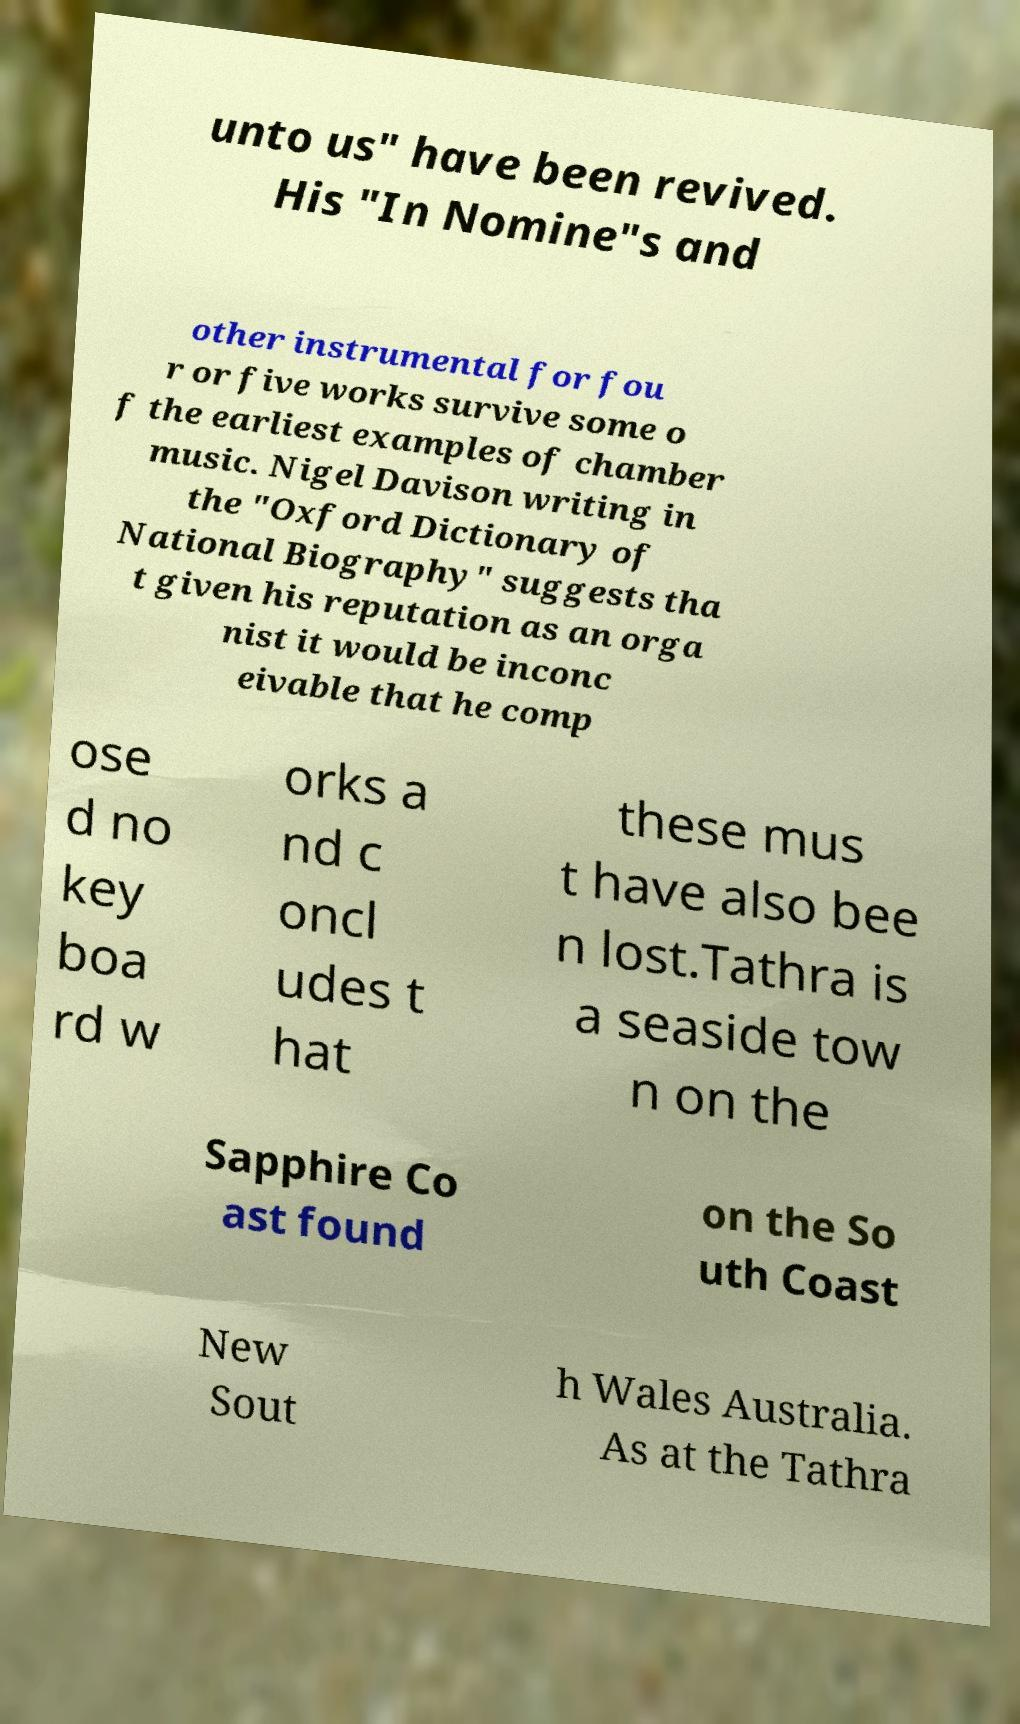What messages or text are displayed in this image? I need them in a readable, typed format. unto us" have been revived. His "In Nomine"s and other instrumental for fou r or five works survive some o f the earliest examples of chamber music. Nigel Davison writing in the "Oxford Dictionary of National Biography" suggests tha t given his reputation as an orga nist it would be inconc eivable that he comp ose d no key boa rd w orks a nd c oncl udes t hat these mus t have also bee n lost.Tathra is a seaside tow n on the Sapphire Co ast found on the So uth Coast New Sout h Wales Australia. As at the Tathra 